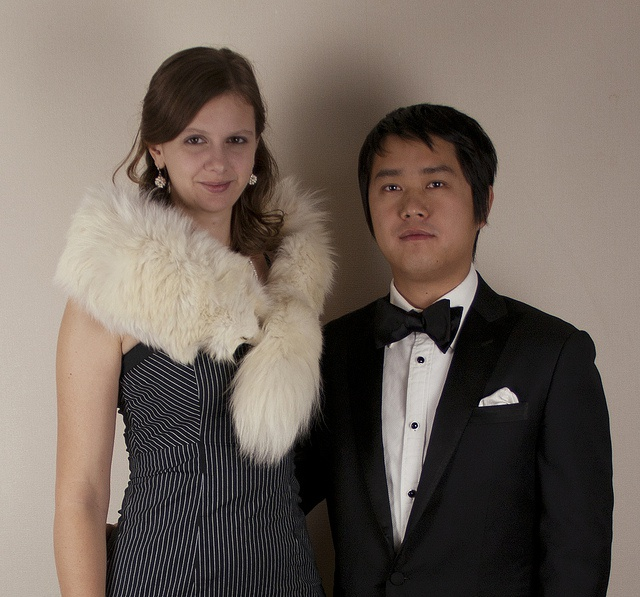Describe the objects in this image and their specific colors. I can see people in darkgray, black, tan, and gray tones, people in darkgray, black, and brown tones, and tie in darkgray, black, and gray tones in this image. 